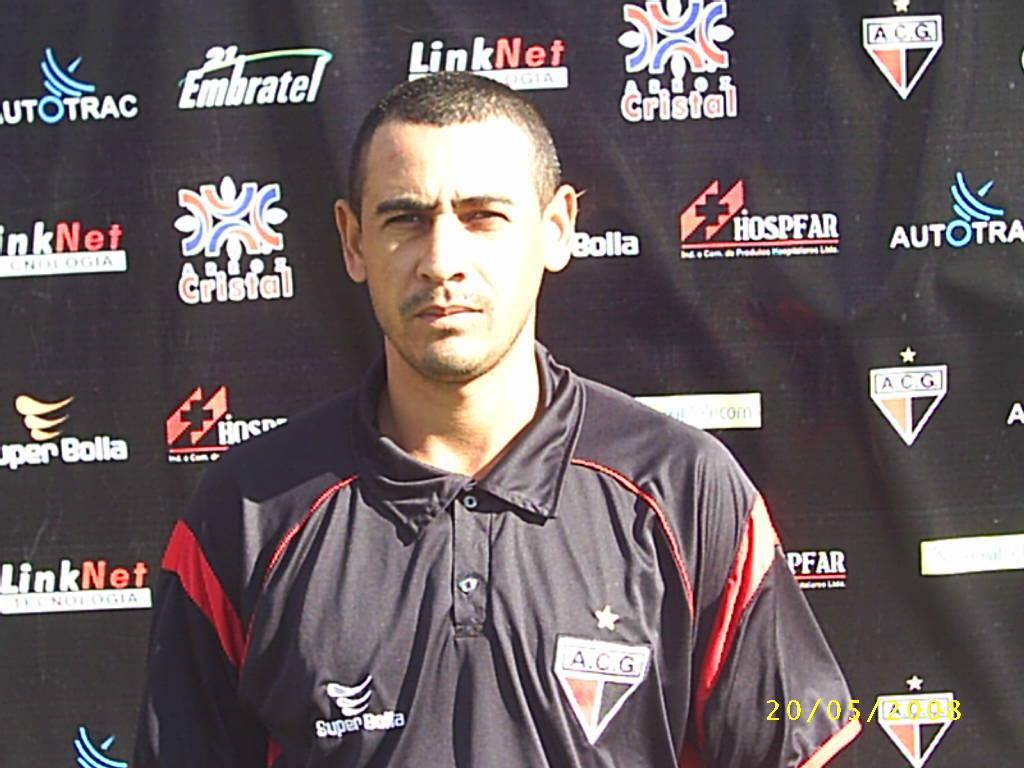<image>
Describe the image concisely. Man wearing a Super Bolta polo in front of a black background. 